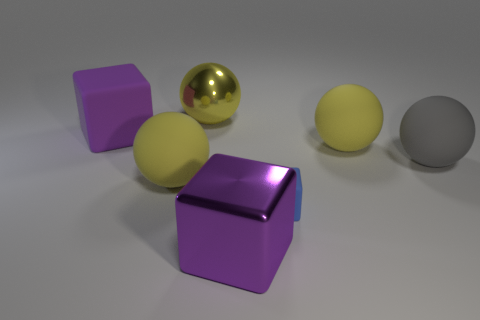Subtract all big metallic balls. How many balls are left? 3 Add 2 yellow metallic spheres. How many objects exist? 9 Subtract all yellow balls. How many balls are left? 1 Subtract 2 spheres. How many spheres are left? 2 Subtract all red balls. How many purple cubes are left? 2 Add 5 small blue cubes. How many small blue cubes are left? 6 Add 2 yellow things. How many yellow things exist? 5 Subtract 0 purple spheres. How many objects are left? 7 Subtract all spheres. How many objects are left? 3 Subtract all gray spheres. Subtract all purple cubes. How many spheres are left? 3 